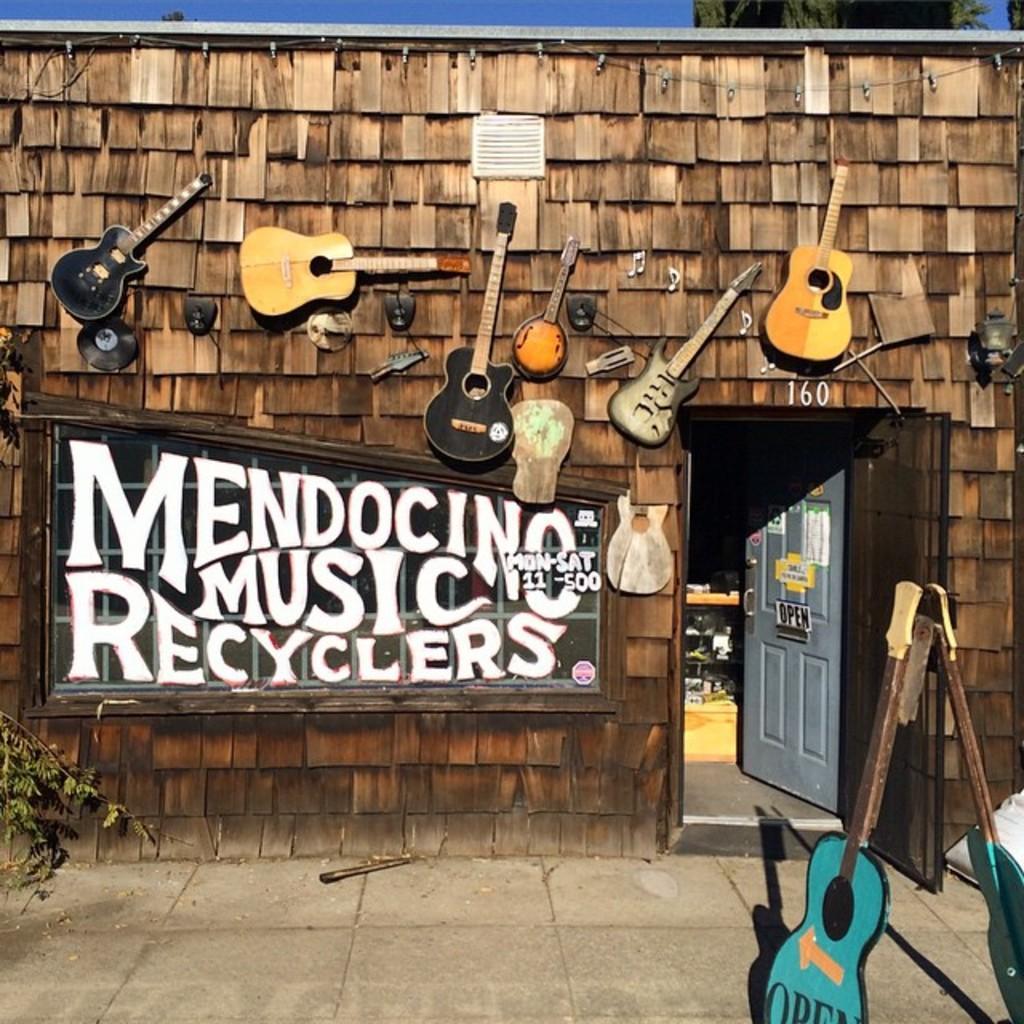Can you describe this image briefly? In this image I can see many guitars and the board attached to the wall. 